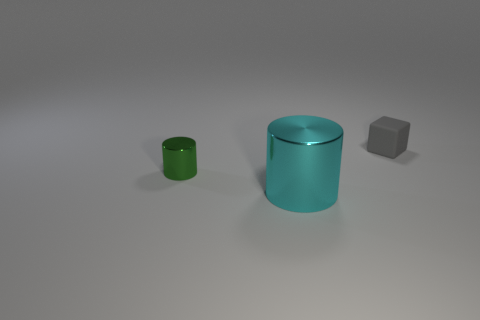Add 3 small gray objects. How many objects exist? 6 Subtract all blocks. How many objects are left? 2 Subtract all large purple matte spheres. Subtract all small gray cubes. How many objects are left? 2 Add 1 gray cubes. How many gray cubes are left? 2 Add 2 gray rubber objects. How many gray rubber objects exist? 3 Subtract 0 blue blocks. How many objects are left? 3 